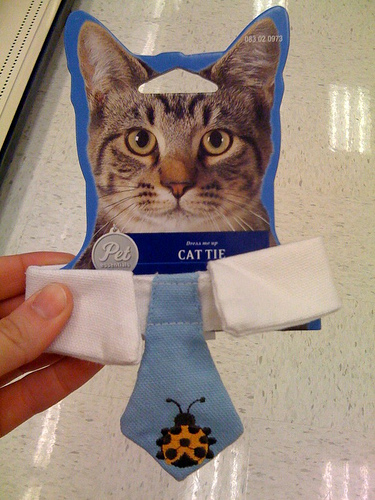Please extract the text content from this image. 083 20 0973 Pet CAT TIF 